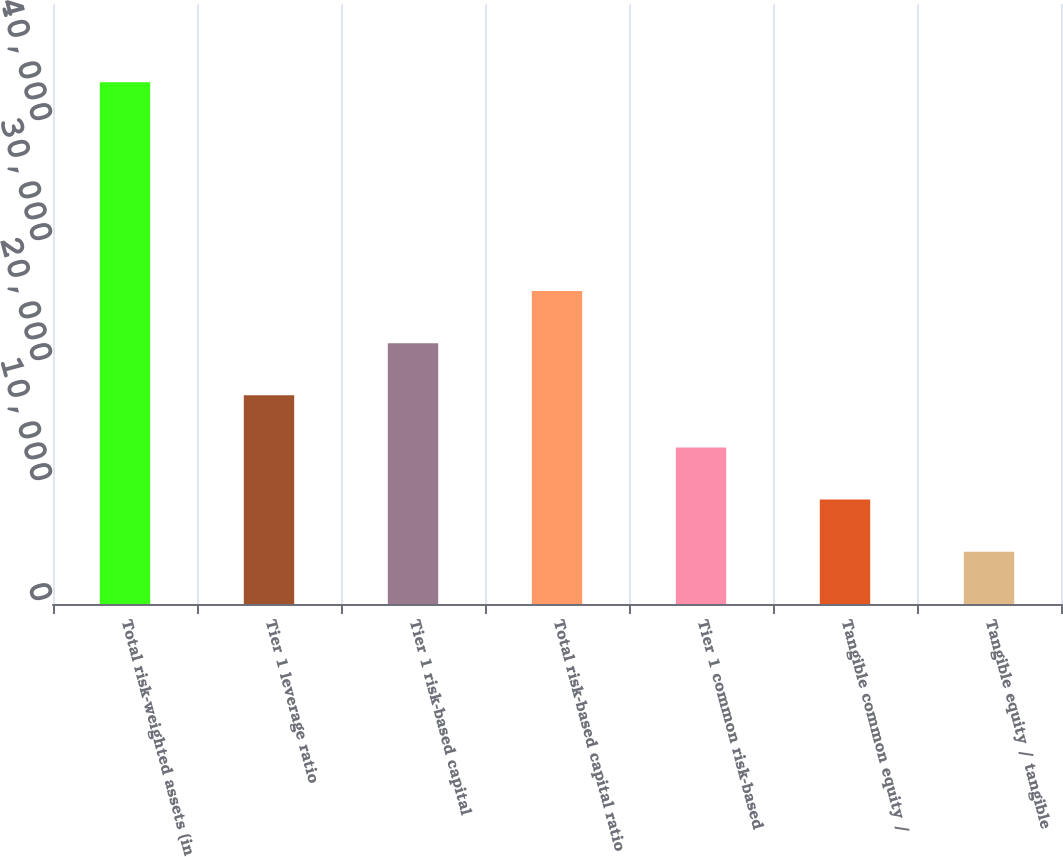<chart> <loc_0><loc_0><loc_500><loc_500><bar_chart><fcel>Total risk-weighted assets (in<fcel>Tier 1 leverage ratio<fcel>Tier 1 risk-based capital<fcel>Total risk-based capital ratio<fcel>Tier 1 common risk-based<fcel>Tangible common equity /<fcel>Tangible equity / tangible<nl><fcel>43471<fcel>17392.9<fcel>21739.3<fcel>26085.6<fcel>13046.6<fcel>8700.24<fcel>4353.9<nl></chart> 